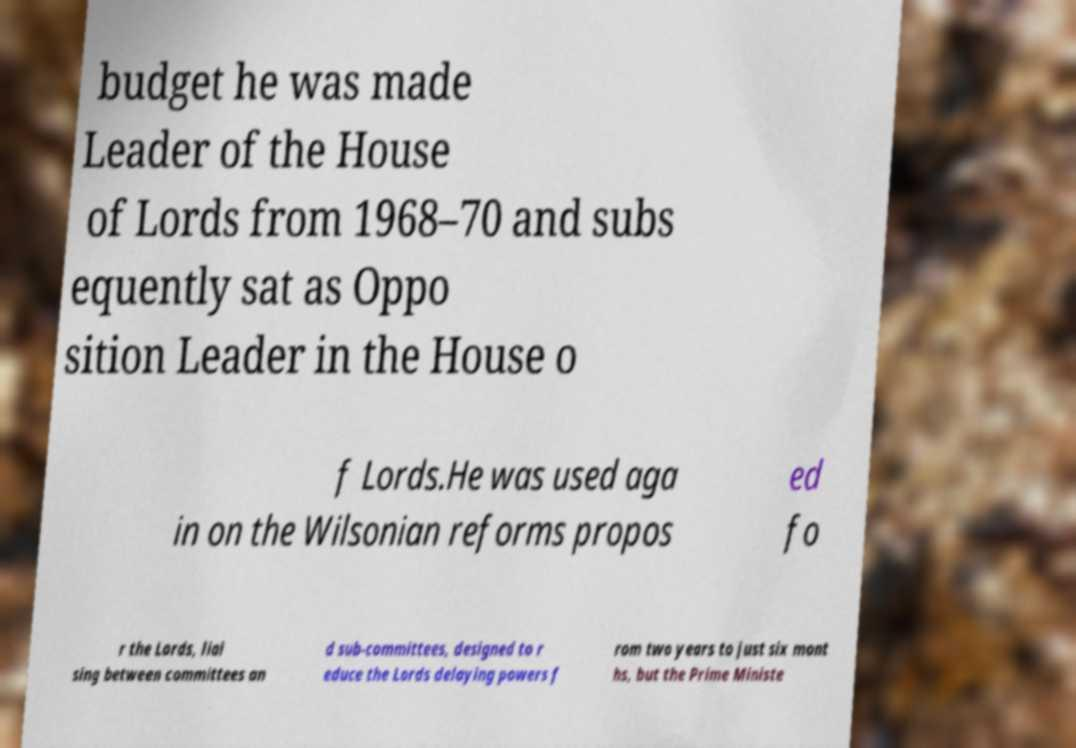There's text embedded in this image that I need extracted. Can you transcribe it verbatim? budget he was made Leader of the House of Lords from 1968–70 and subs equently sat as Oppo sition Leader in the House o f Lords.He was used aga in on the Wilsonian reforms propos ed fo r the Lords, liai sing between committees an d sub-committees, designed to r educe the Lords delaying powers f rom two years to just six mont hs, but the Prime Ministe 